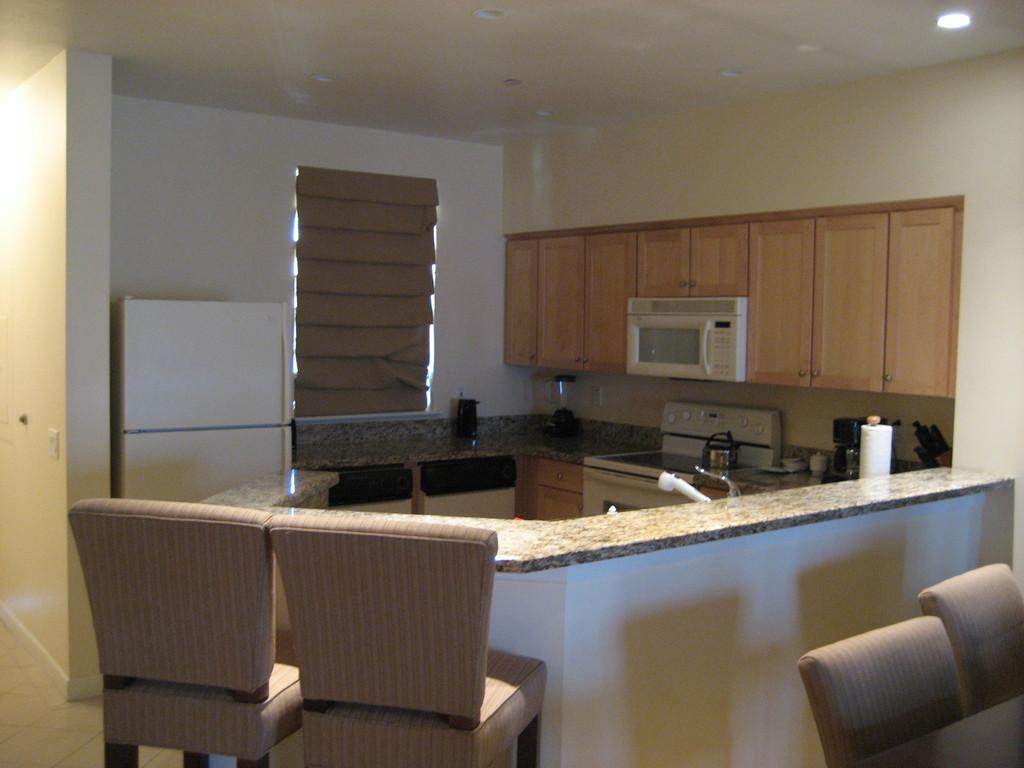What type of furniture can be seen in the image? There are chairs in the image. What type of structure is visible in the image? There is a wall in the image. What type of storage units are present in the image? There are cupboards in the image. What can be found in the image besides furniture and storage units? There are objects in the image. What part of a building can be seen in the background of the image? There is a roof visible in the background of the image. What type of instrument is being played by the friend in the image? There is no friend or instrument present in the image. Where is the playground located in the image? There is no playground present in the image. 